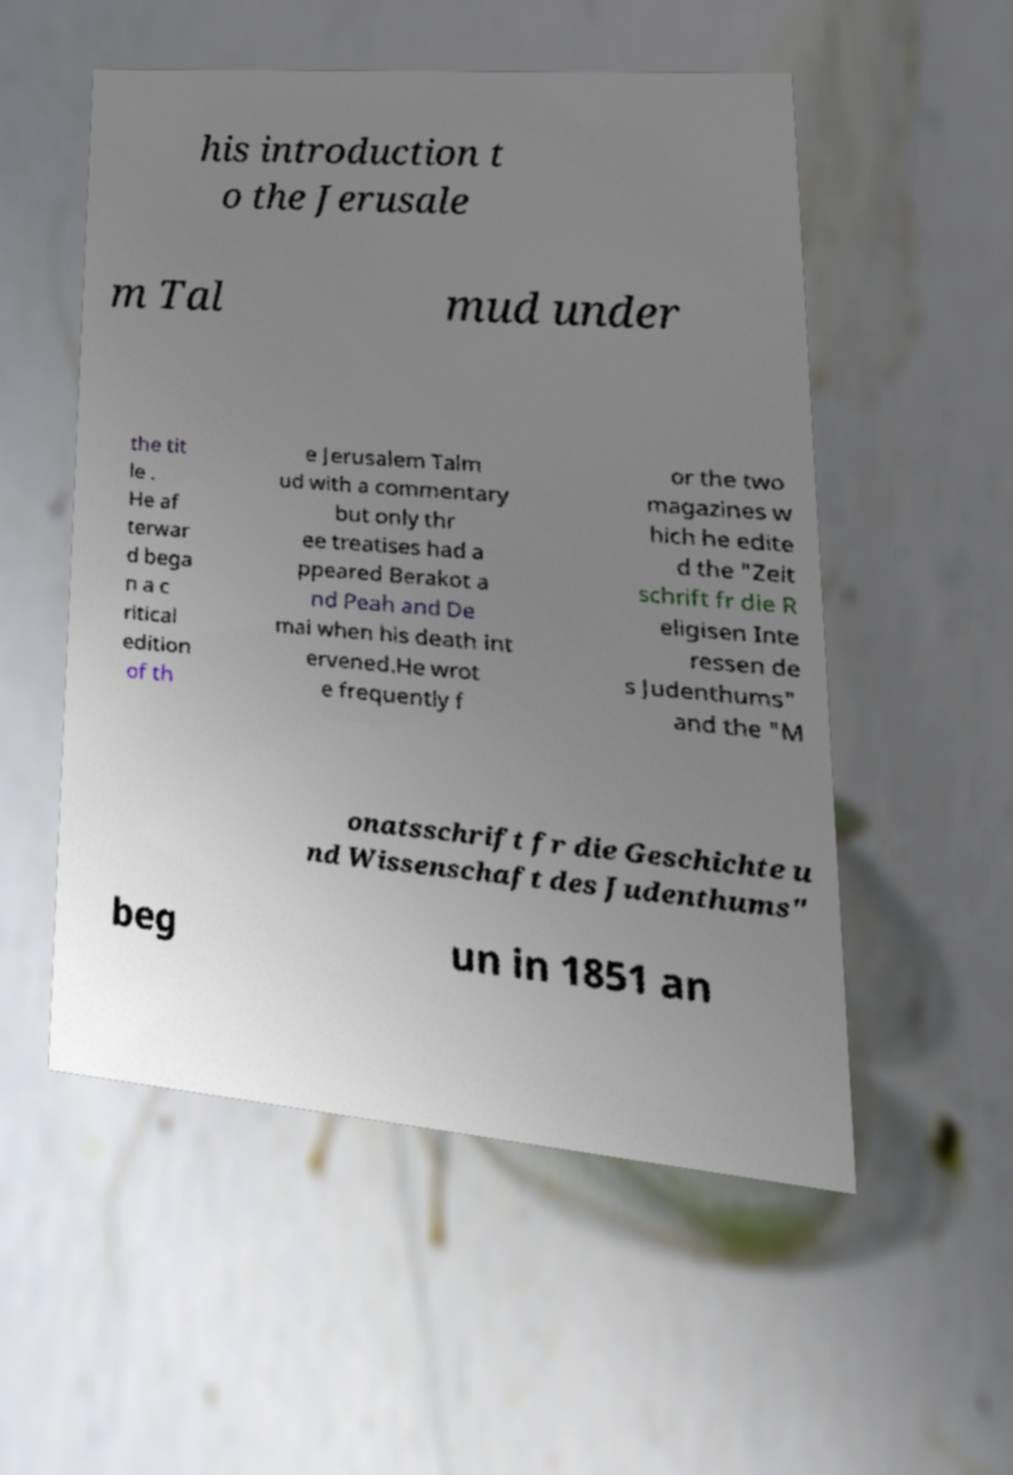I need the written content from this picture converted into text. Can you do that? his introduction t o the Jerusale m Tal mud under the tit le . He af terwar d bega n a c ritical edition of th e Jerusalem Talm ud with a commentary but only thr ee treatises had a ppeared Berakot a nd Peah and De mai when his death int ervened.He wrot e frequently f or the two magazines w hich he edite d the "Zeit schrift fr die R eligisen Inte ressen de s Judenthums" and the "M onatsschrift fr die Geschichte u nd Wissenschaft des Judenthums" beg un in 1851 an 